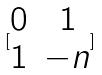<formula> <loc_0><loc_0><loc_500><loc_500>[ \begin{matrix} 0 & 1 \\ 1 & - n \end{matrix} ]</formula> 